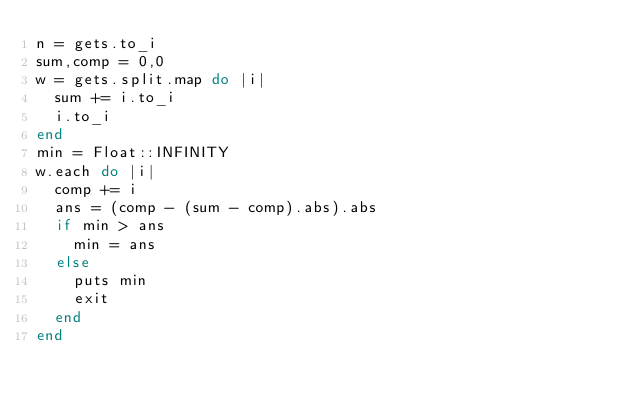Convert code to text. <code><loc_0><loc_0><loc_500><loc_500><_Ruby_>n = gets.to_i
sum,comp = 0,0
w = gets.split.map do |i|
  sum += i.to_i
  i.to_i
end
min = Float::INFINITY
w.each do |i|
  comp += i
  ans = (comp - (sum - comp).abs).abs
  if min > ans
    min = ans
  else
    puts min
    exit
  end
end
</code> 